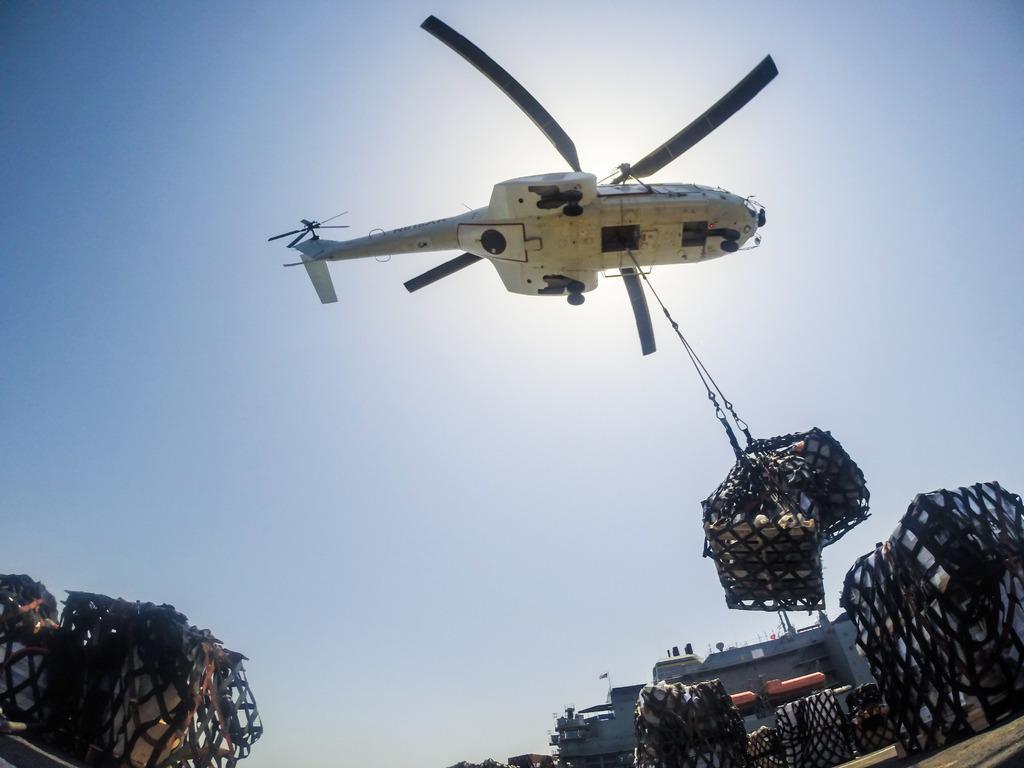Can you describe this image briefly? In this image I can see an aircraft which is in white color, I can also see few objects in the net. Background I can see a building in gray color and sky in blue and white color. 